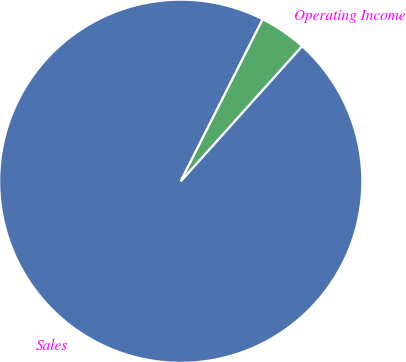<chart> <loc_0><loc_0><loc_500><loc_500><pie_chart><fcel>Sales<fcel>Operating Income<nl><fcel>95.81%<fcel>4.19%<nl></chart> 